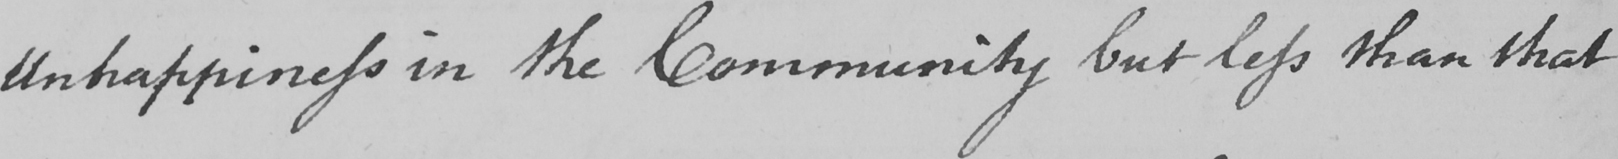What text is written in this handwritten line? Unhappiness in the Community but less than that 